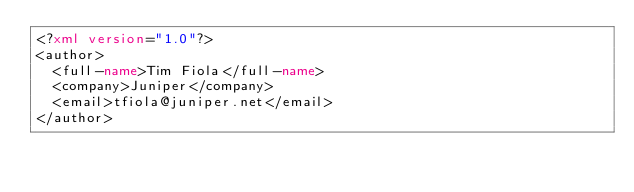<code> <loc_0><loc_0><loc_500><loc_500><_XML_><?xml version="1.0"?>
<author>
  <full-name>Tim Fiola</full-name>
  <company>Juniper</company>
  <email>tfiola@juniper.net</email>
</author>
</code> 